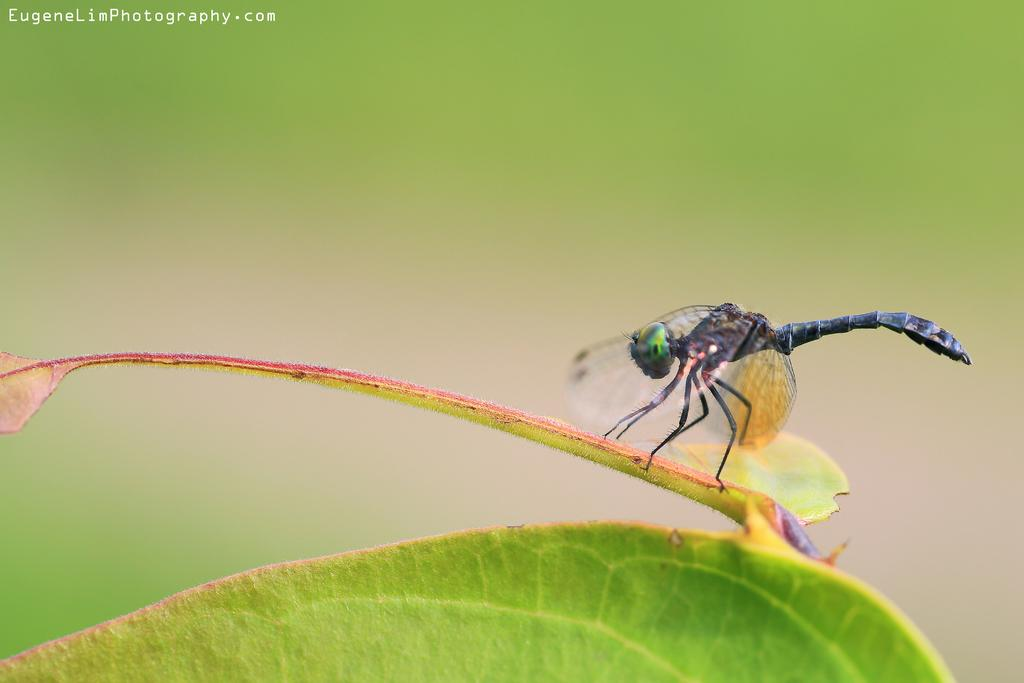What is the main subject of the image? There is an insect in the image. Where is the insect located? The insect is sitting on a leaf. Can you describe the background of the image? The background of the image is blurred. How does the worm measure the distance between the rock and the insect in the image? There is no worm or rock present in the image, so it is not possible to determine how a worm might measure any distance. 